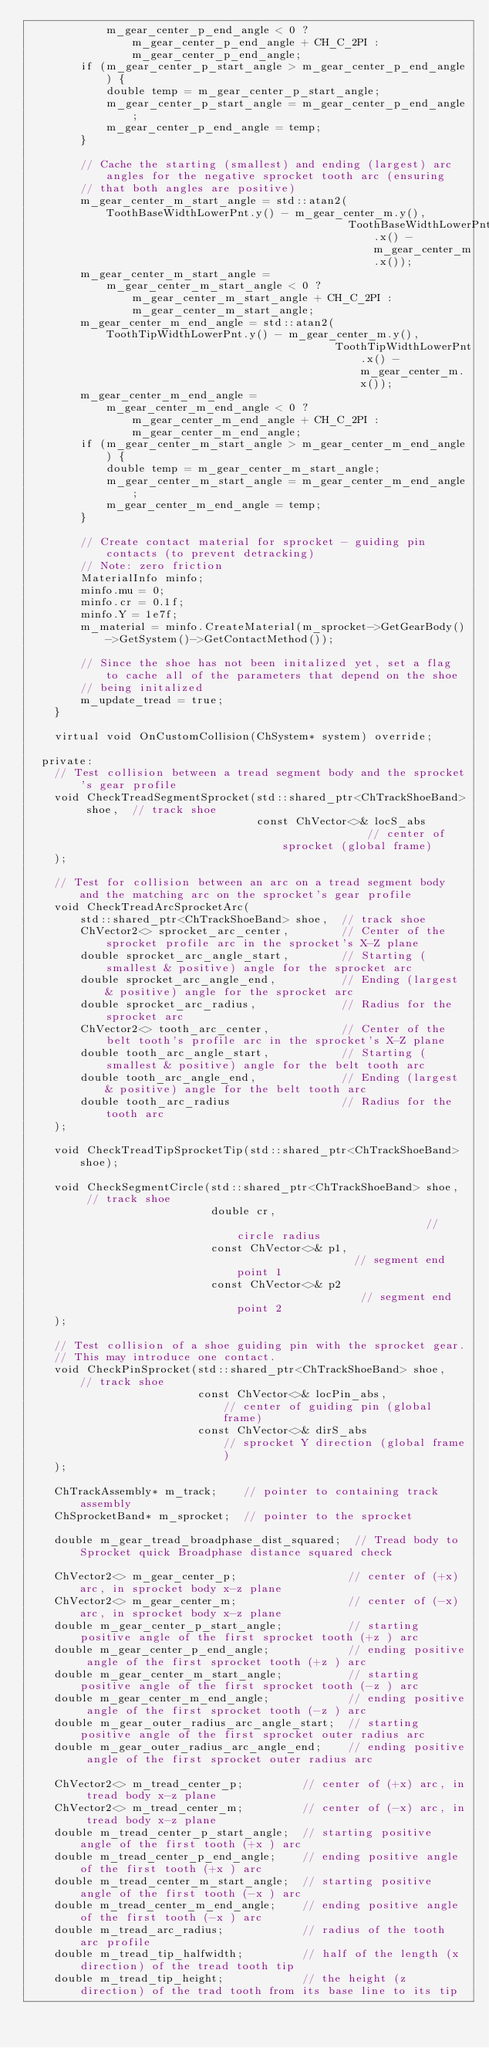<code> <loc_0><loc_0><loc_500><loc_500><_C++_>            m_gear_center_p_end_angle < 0 ? m_gear_center_p_end_angle + CH_C_2PI : m_gear_center_p_end_angle;
        if (m_gear_center_p_start_angle > m_gear_center_p_end_angle) {
            double temp = m_gear_center_p_start_angle;
            m_gear_center_p_start_angle = m_gear_center_p_end_angle;
            m_gear_center_p_end_angle = temp;
        }

        // Cache the starting (smallest) and ending (largest) arc angles for the negative sprocket tooth arc (ensuring
        // that both angles are positive)
        m_gear_center_m_start_angle = std::atan2(ToothBaseWidthLowerPnt.y() - m_gear_center_m.y(),
                                                 ToothBaseWidthLowerPnt.x() - m_gear_center_m.x());
        m_gear_center_m_start_angle =
            m_gear_center_m_start_angle < 0 ? m_gear_center_m_start_angle + CH_C_2PI : m_gear_center_m_start_angle;
        m_gear_center_m_end_angle = std::atan2(ToothTipWidthLowerPnt.y() - m_gear_center_m.y(),
                                               ToothTipWidthLowerPnt.x() - m_gear_center_m.x());
        m_gear_center_m_end_angle =
            m_gear_center_m_end_angle < 0 ? m_gear_center_m_end_angle + CH_C_2PI : m_gear_center_m_end_angle;
        if (m_gear_center_m_start_angle > m_gear_center_m_end_angle) {
            double temp = m_gear_center_m_start_angle;
            m_gear_center_m_start_angle = m_gear_center_m_end_angle;
            m_gear_center_m_end_angle = temp;
        }

        // Create contact material for sprocket - guiding pin contacts (to prevent detracking)
        // Note: zero friction
        MaterialInfo minfo;
        minfo.mu = 0;
        minfo.cr = 0.1f;
        minfo.Y = 1e7f;
        m_material = minfo.CreateMaterial(m_sprocket->GetGearBody()->GetSystem()->GetContactMethod());

        // Since the shoe has not been initalized yet, set a flag to cache all of the parameters that depend on the shoe
        // being initalized
        m_update_tread = true;
    }

    virtual void OnCustomCollision(ChSystem* system) override;

  private:
    // Test collision between a tread segment body and the sprocket's gear profile
    void CheckTreadSegmentSprocket(std::shared_ptr<ChTrackShoeBand> shoe,  // track shoe
                                   const ChVector<>& locS_abs              // center of sprocket (global frame)
    );

    // Test for collision between an arc on a tread segment body and the matching arc on the sprocket's gear profile
    void CheckTreadArcSprocketArc(
        std::shared_ptr<ChTrackShoeBand> shoe,  // track shoe
        ChVector2<> sprocket_arc_center,        // Center of the sprocket profile arc in the sprocket's X-Z plane
        double sprocket_arc_angle_start,        // Starting (smallest & positive) angle for the sprocket arc
        double sprocket_arc_angle_end,          // Ending (largest & positive) angle for the sprocket arc
        double sprocket_arc_radius,             // Radius for the sprocket arc
        ChVector2<> tooth_arc_center,           // Center of the belt tooth's profile arc in the sprocket's X-Z plane
        double tooth_arc_angle_start,           // Starting (smallest & positive) angle for the belt tooth arc
        double tooth_arc_angle_end,             // Ending (largest & positive) angle for the belt tooth arc
        double tooth_arc_radius                 // Radius for the tooth arc
    );

    void CheckTreadTipSprocketTip(std::shared_ptr<ChTrackShoeBand> shoe);

    void CheckSegmentCircle(std::shared_ptr<ChTrackShoeBand> shoe,  // track shoe
                            double cr,                              // circle radius
                            const ChVector<>& p1,                   // segment end point 1
                            const ChVector<>& p2                    // segment end point 2
    );

    // Test collision of a shoe guiding pin with the sprocket gear.
    // This may introduce one contact.
    void CheckPinSprocket(std::shared_ptr<ChTrackShoeBand> shoe,  // track shoe
                          const ChVector<>& locPin_abs,           // center of guiding pin (global frame)
                          const ChVector<>& dirS_abs              // sprocket Y direction (global frame)
    );

    ChTrackAssembly* m_track;    // pointer to containing track assembly
    ChSprocketBand* m_sprocket;  // pointer to the sprocket

    double m_gear_tread_broadphase_dist_squared;  // Tread body to Sprocket quick Broadphase distance squared check

    ChVector2<> m_gear_center_p;                 // center of (+x) arc, in sprocket body x-z plane
    ChVector2<> m_gear_center_m;                 // center of (-x) arc, in sprocket body x-z plane
    double m_gear_center_p_start_angle;          // starting positive angle of the first sprocket tooth (+z ) arc
    double m_gear_center_p_end_angle;            // ending positive angle of the first sprocket tooth (+z ) arc
    double m_gear_center_m_start_angle;          // starting positive angle of the first sprocket tooth (-z ) arc
    double m_gear_center_m_end_angle;            // ending positive angle of the first sprocket tooth (-z ) arc
    double m_gear_outer_radius_arc_angle_start;  // starting positive angle of the first sprocket outer radius arc
    double m_gear_outer_radius_arc_angle_end;    // ending positive angle of the first sprocket outer radius arc

    ChVector2<> m_tread_center_p;         // center of (+x) arc, in tread body x-z plane
    ChVector2<> m_tread_center_m;         // center of (-x) arc, in tread body x-z plane
    double m_tread_center_p_start_angle;  // starting positive angle of the first tooth (+x ) arc
    double m_tread_center_p_end_angle;    // ending positive angle of the first tooth (+x ) arc
    double m_tread_center_m_start_angle;  // starting positive angle of the first tooth (-x ) arc
    double m_tread_center_m_end_angle;    // ending positive angle of the first tooth (-x ) arc
    double m_tread_arc_radius;            // radius of the tooth arc profile
    double m_tread_tip_halfwidth;         // half of the length (x direction) of the tread tooth tip
    double m_tread_tip_height;            // the height (z direction) of the trad tooth from its base line to its tip
</code> 